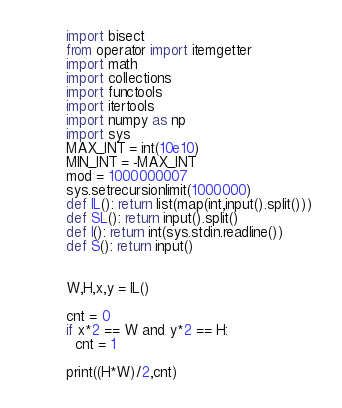<code> <loc_0><loc_0><loc_500><loc_500><_Python_>import bisect
from operator import itemgetter
import math
import collections
import functools
import itertools
import numpy as np
import sys
MAX_INT = int(10e10)
MIN_INT = -MAX_INT
mod = 1000000007
sys.setrecursionlimit(1000000)
def IL(): return list(map(int,input().split()))
def SL(): return input().split()
def I(): return int(sys.stdin.readline())
def S(): return input()


W,H,x,y = IL()

cnt = 0
if x*2 == W and y*2 == H:
  cnt = 1

print((H*W)/2,cnt)</code> 